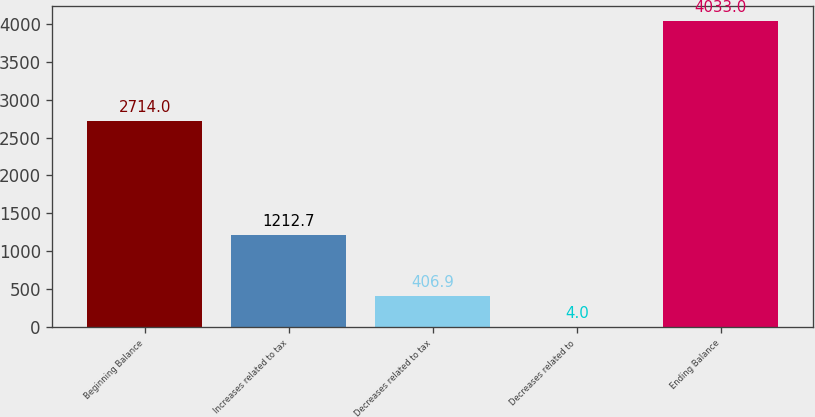Convert chart to OTSL. <chart><loc_0><loc_0><loc_500><loc_500><bar_chart><fcel>Beginning Balance<fcel>Increases related to tax<fcel>Decreases related to tax<fcel>Decreases related to<fcel>Ending Balance<nl><fcel>2714<fcel>1212.7<fcel>406.9<fcel>4<fcel>4033<nl></chart> 